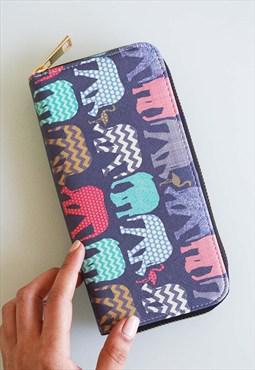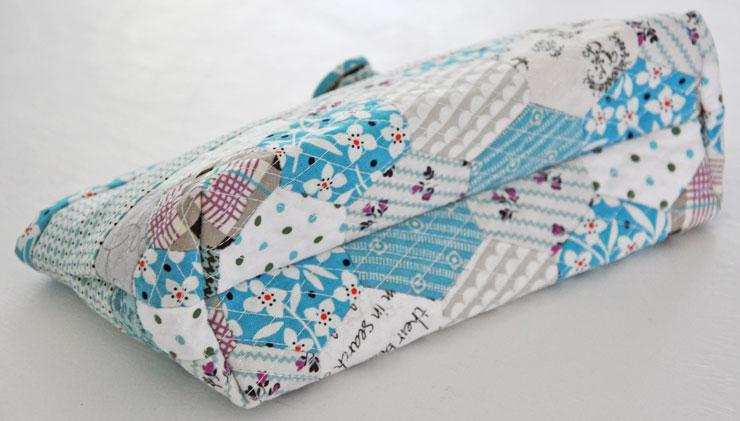The first image is the image on the left, the second image is the image on the right. Analyze the images presented: Is the assertion "A hand is touching at least one rectangular patterned item in one image." valid? Answer yes or no. Yes. The first image is the image on the left, the second image is the image on the right. Analyze the images presented: Is the assertion "A human hand is touchin a school supply." valid? Answer yes or no. Yes. 